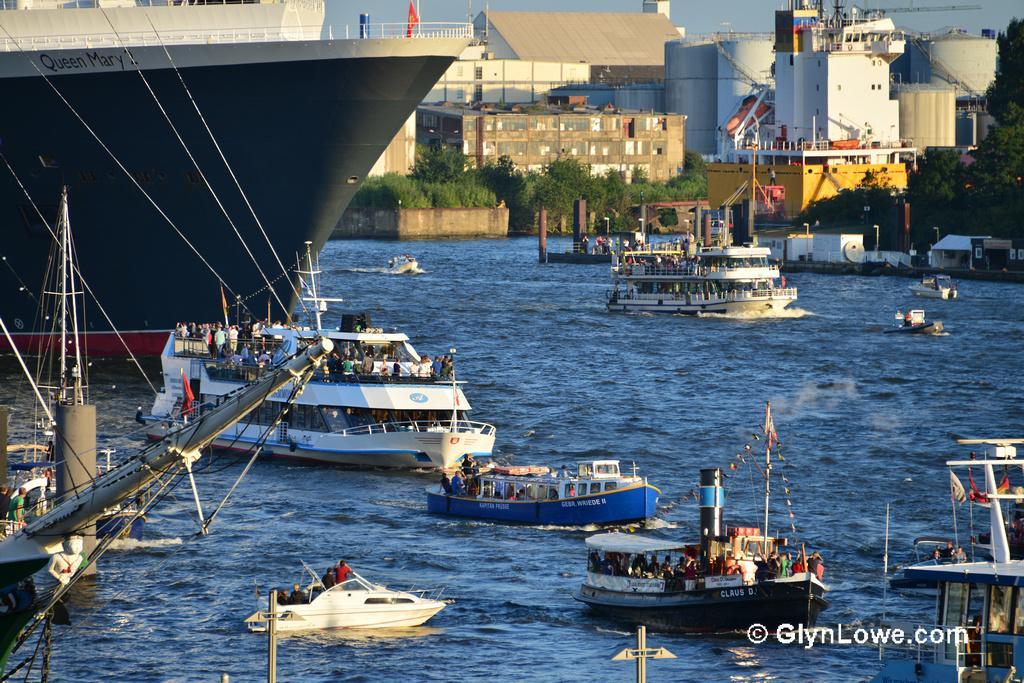How would you summarize this image in a sentence or two? This is completely an outdoor picture. This is a sea. Here we can see ships. On the background of the picture we can see huge buildings. These are the trees. 